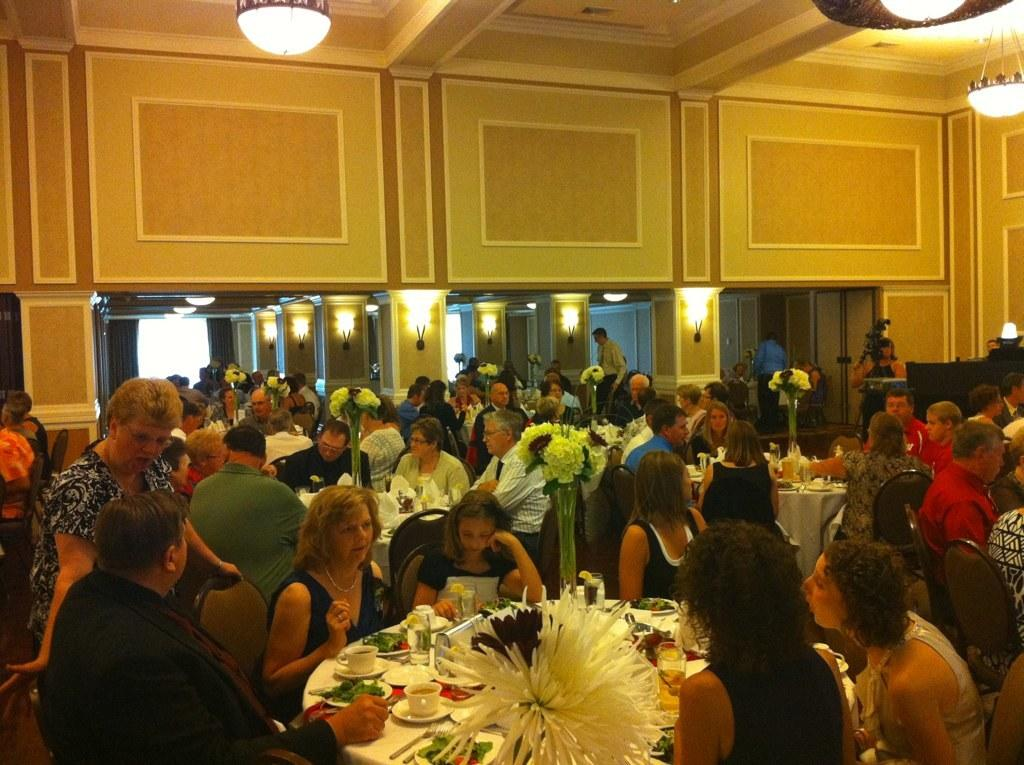What type of furniture is present in the image? There are tables in the image. What are the people sitting on in the image? There are people sitting on chairs in the image. What can be seen in the background of the image? There is a wall visible in the image. What provides illumination in the image? There are lights in the image. How many babies can be seen in the image? There is no baby present in the image. What color is the nose of the person sitting on the chair? There is no nose visible in the image, as the people are only shown from the waist up. 